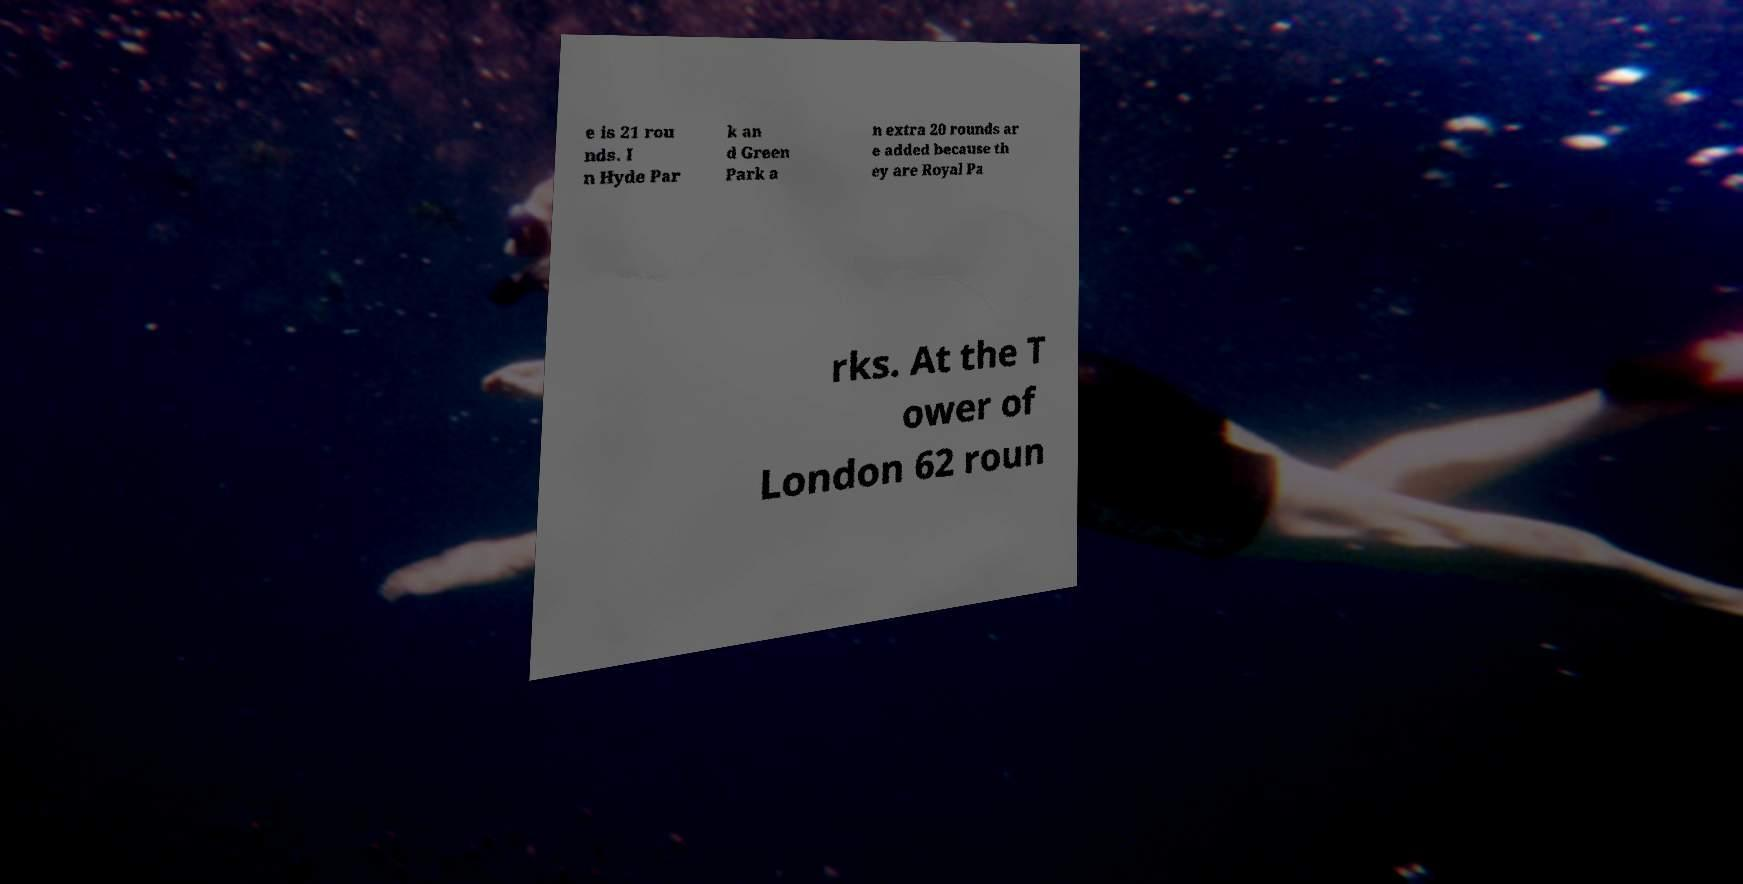Can you accurately transcribe the text from the provided image for me? e is 21 rou nds. I n Hyde Par k an d Green Park a n extra 20 rounds ar e added because th ey are Royal Pa rks. At the T ower of London 62 roun 